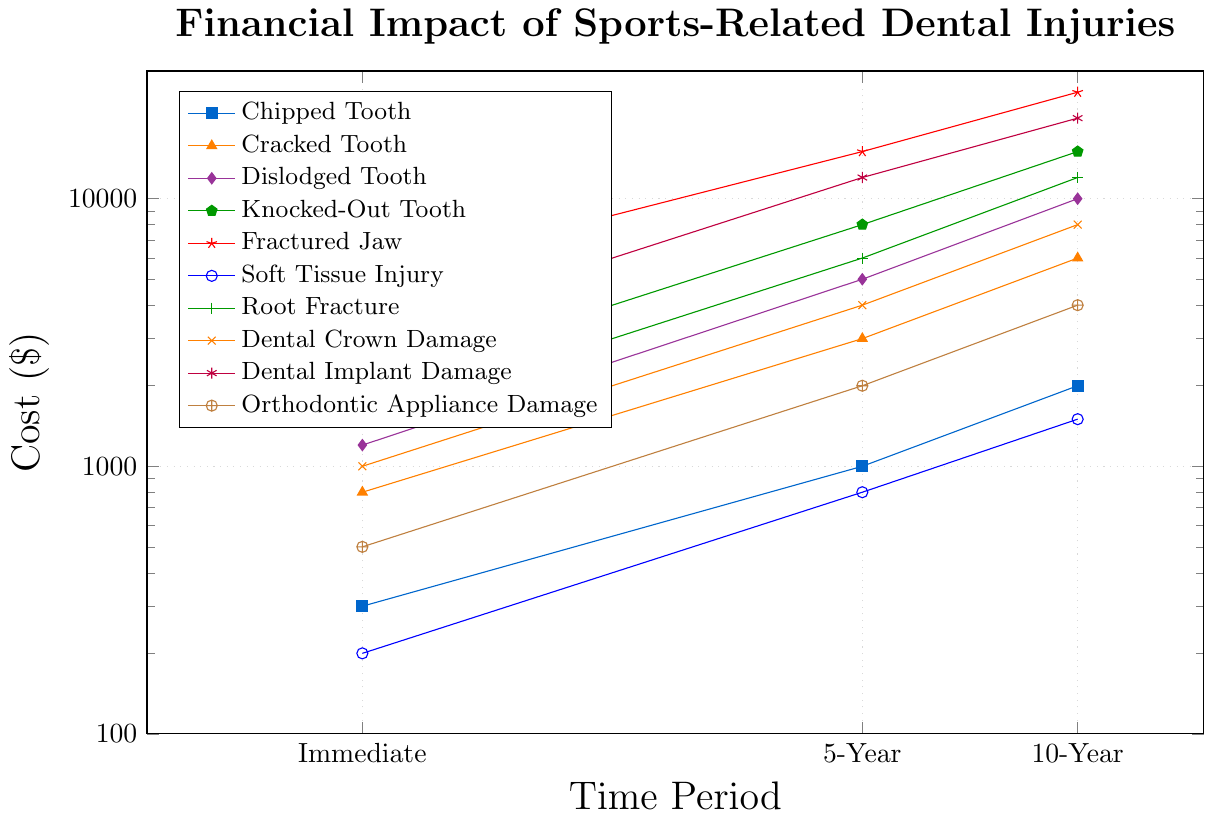Which injury type has the highest immediate cost? The immediate costs are all plotted, and the highest point for the immediate time is 5000, which corresponds to "Fractured Jaw."
Answer: Fractured Jaw What is the approximate increase in cost from immediate to 10-year for a Dislodged Tooth? The immediate cost for a Dislodged Tooth is 1200, and the 10-year cost is 10000. The increase is 10000 - 1200 = 8800.
Answer: 8800 By how much does the cost of a Root Fracture increase from a 1-year to a 5-year timeframe? The 1-year cost for a Root Fracture is not plotted directly, but the immediate cost and 10-year costs allow estimation of the pattern. For simplicity, let's take the provided data: 1-year (1500) to 5-year (6000). The increase is 6000 - 1500 = 4500.
Answer: 4500 Which injuries have a lower 10-year cost than the immediate cost of a Fractured Jaw? The immediate cost of a Fractured Jaw is 5000. The injuries with 10-year costs lower than 5000 are "Soft Tissue Injury" (1500) and "Orthodontic Appliance Damage" (4000).
Answer: Soft Tissue Injury, Orthodontic Appliance Damage For how many injuries is the 5-year cost exactly double the immediate cost? By checking each injury type, we can see that "Chipped Tooth," "Cracked Tooth," "Dental Crown Damage," "Dental Implant Damage," and "Orthodontic Appliance Damage" have 5-year costs more than double their immediate costs, meaning none have exactly double.
Answer: 0 Which injury type has the steepest cost growth from immediate to 10-year? Steep growth can be seen by the highest percentage change. For "Knocked-Out Tooth," immediate cost is 2000, and 10-year is 15000, showing a significant increase.
Answer: Knocked-Out Tooth Is any injury type showing a linear relationship in cost growth on this log-log scale? On a log-log scale, a linear relationship would appear as a straight line. By observing the plots, "Fractured Jaw" might show an approximately linear relationship.
Answer: Fractured Jaw Which injury types have an immediate cost less than or equal to 1000 and also fall in the lowest 5-year cost range? The immediate costs <= 1000 are "Chipped Tooth," "Soft Tissue Injury," and "Orthodontic Appliance Damage." Their 5-year costs are 1000, 800, and 2000 respectively. So only "Soft Tissue Injury" has the lowest 5-year cost.
Answer: Soft Tissue Injury If you wanted to minimize both immediate and 10-year costs, which injury type would be the best to avoid? "Soft Tissue Injury" has both the lowest immediate (200) and 10-year costs (1500).
Answer: Soft Tissue Injury Between "Dental Crown Damage" and "Root Fracture," which has a higher cost at the 5-year mark? "Dental Crown Damage" 5-year cost is 4000, while "Root Fracture" is 6000. So, "Root Fracture" is higher.
Answer: Root Fracture 